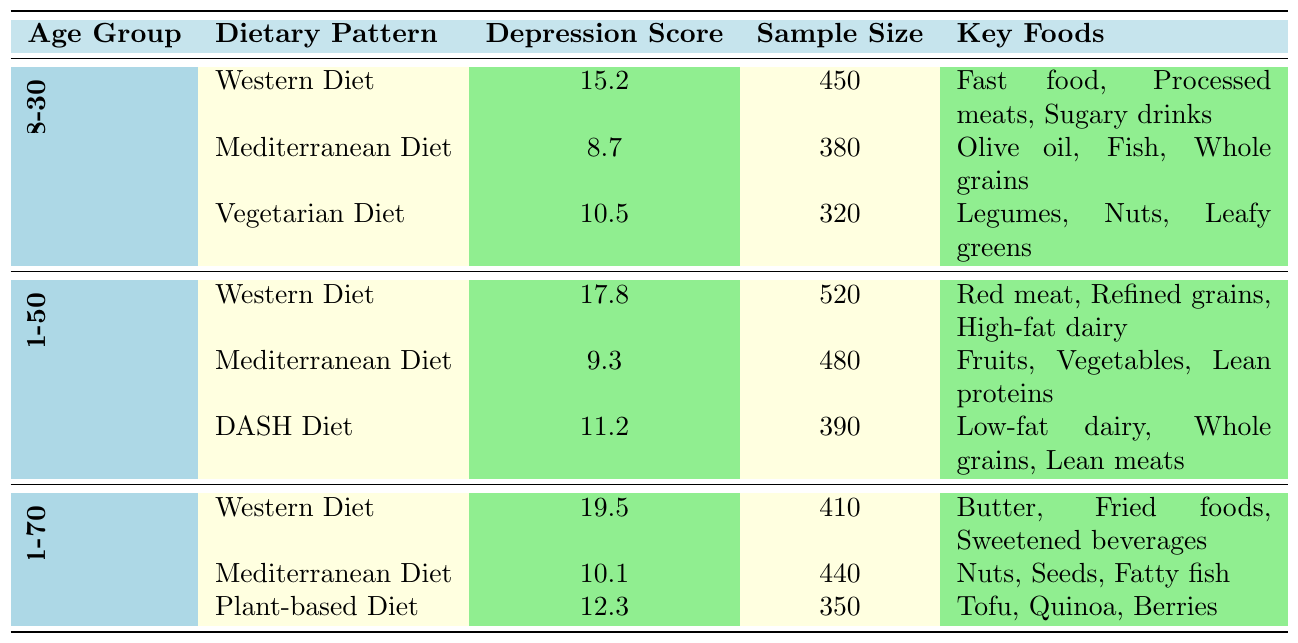What is the depression score for the Mediterranean Diet in the 18-30 age group? The depression score for the Mediterranean Diet can be found in the table under the 18-30 age group. It states that the depression score is 8.7.
Answer: 8.7 How many individuals were sampled for the Western Diet in the 31-50 age group? The sample size for the Western Diet in the 31-50 age group is listed in the table as 520 individuals.
Answer: 520 What is the depression score for the Plant-based Diet in the 51-70 age group? The depression score for the Plant-based Diet is stated in the table under the 51-70 age group as 12.3.
Answer: 12.3 Which age group has the highest depression score associated with the Western Diet? The table shows that the Western Diet's depression scores for different age groups are 15.2 (18-30), 17.8 (31-50), and 19.5 (51-70). The highest score is 19.5 in the 51-70 age group.
Answer: 51-70 What is the average depression score for all three dietary patterns in the 31-50 age group? The depression scores for the 31-50 age group are 17.8 (Western Diet), 9.3 (Mediterranean Diet), and 11.2 (DASH Diet). The average is calculated as (17.8 + 9.3 + 11.2) / 3 = 12.77.
Answer: 12.77 Is the depression score for the Vegetarian Diet higher than that for the DASH Diet in the 31-50 age group? The Vegetarian Diet score is not listed for the 31-50 age group, but the DASH Diet score is 11.2. Since we cannot compare, the answer is no.
Answer: No Which dietary pattern across all age groups has the lowest depression score? The lowest depression score listed in the table is from the Mediterranean Diet in the 18-30 age group with a score of 8.7.
Answer: Mediterranean Diet (8.7) If we compare the average sample size of all the dietary patterns in the 18-30 and 31-50 age groups, which age group has a larger average sample size? The sample sizes for the 18-30 age group are 450, 380, and 320; their average is (450 + 380 + 320) / 3 = 383.33. The sample sizes for the 31-50 age group are 520, 480, and 390; their average is (520 + 480 + 390) / 3 = 463.33. Thus, the 31-50 age group has a larger average sample size.
Answer: 31-50 What is the total depression score for the Western Diet across all age groups? The total depression score for the Western Diet is found by adding the scores: 15.2 (18-30) + 17.8 (31-50) + 19.5 (51-70) = 52.5.
Answer: 52.5 Which age group has the lowest depression score for the Mediterranean Diet? The Mediterranean Diet depression scores are 8.7 (18-30), 9.3 (31-50), and 10.1 (51-70). The lowest score is 8.7 in the 18-30 age group.
Answer: 18-30 